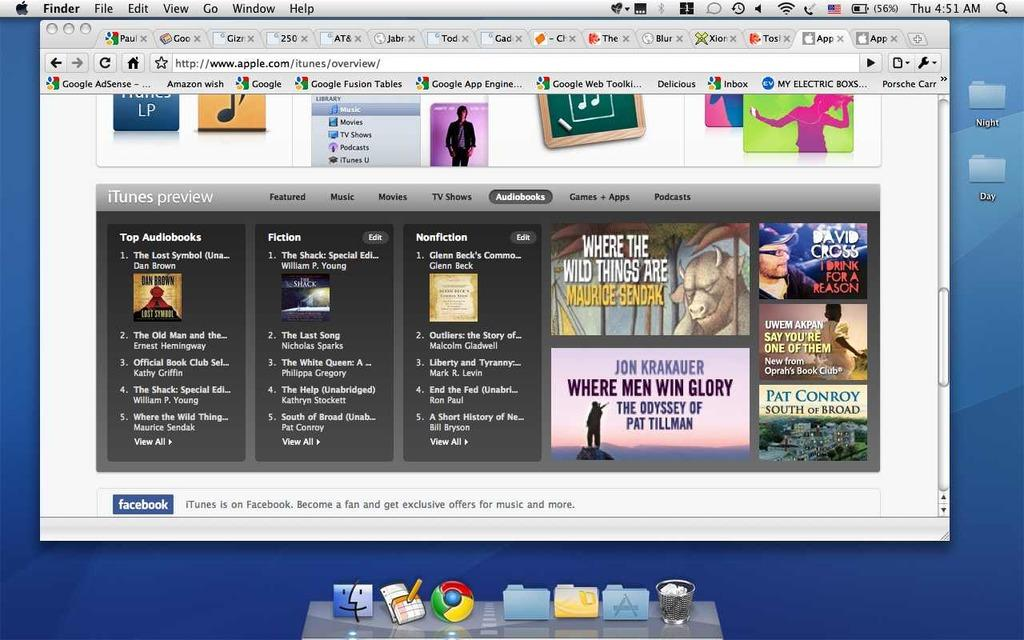<image>
Share a concise interpretation of the image provided. A web browser showing the web site for itunes. 